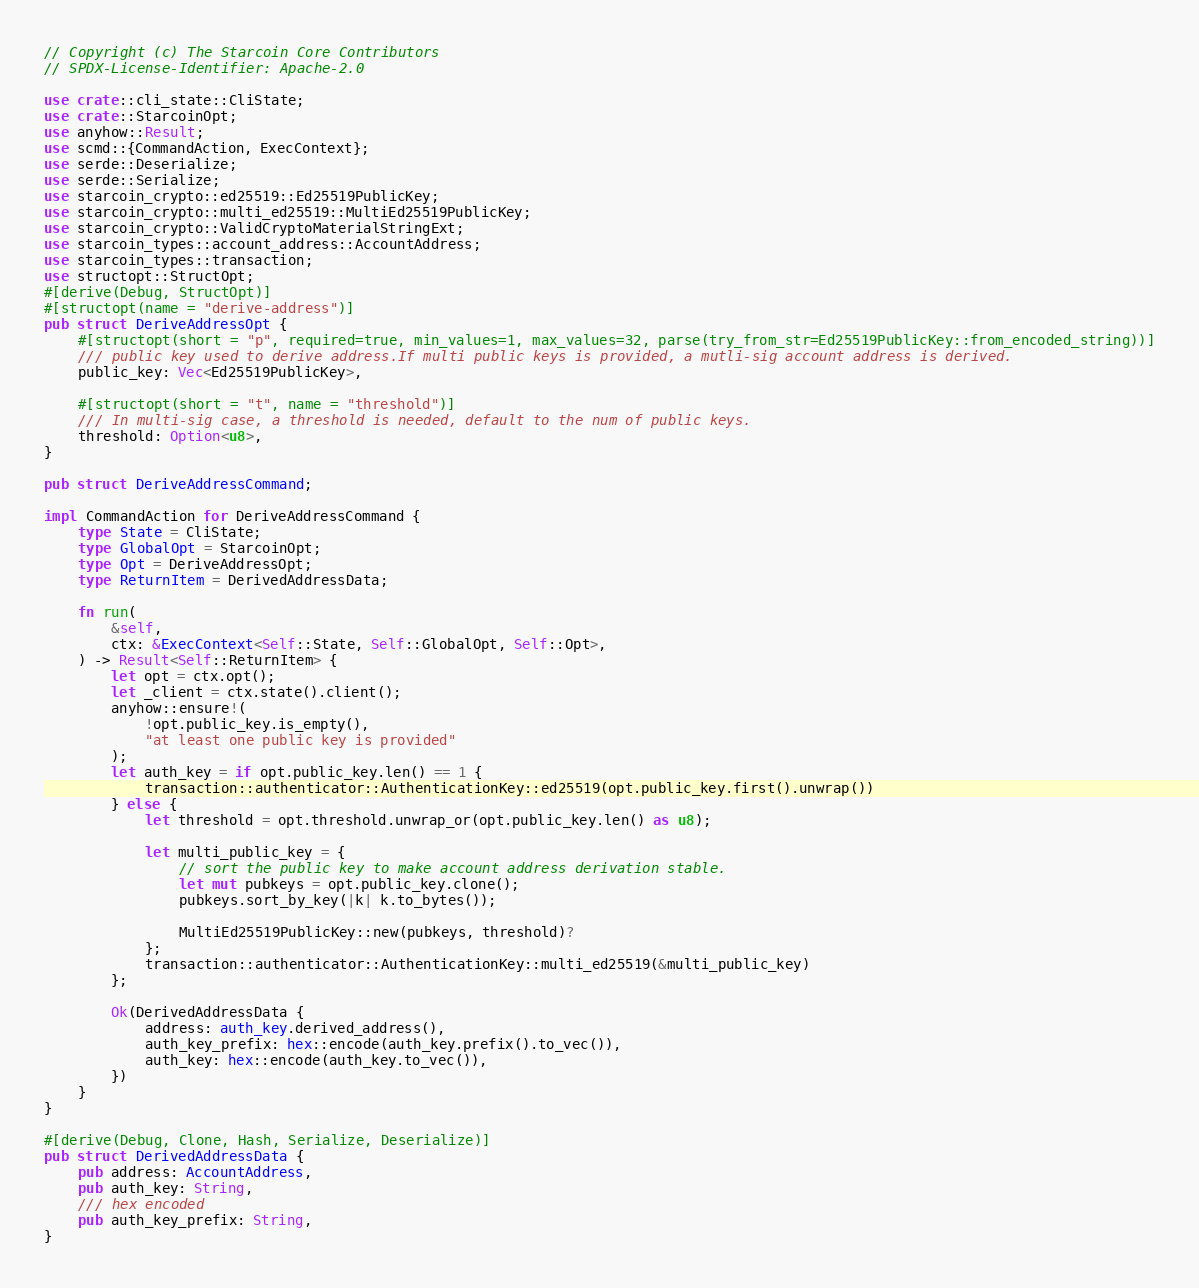Convert code to text. <code><loc_0><loc_0><loc_500><loc_500><_Rust_>// Copyright (c) The Starcoin Core Contributors
// SPDX-License-Identifier: Apache-2.0

use crate::cli_state::CliState;
use crate::StarcoinOpt;
use anyhow::Result;
use scmd::{CommandAction, ExecContext};
use serde::Deserialize;
use serde::Serialize;
use starcoin_crypto::ed25519::Ed25519PublicKey;
use starcoin_crypto::multi_ed25519::MultiEd25519PublicKey;
use starcoin_crypto::ValidCryptoMaterialStringExt;
use starcoin_types::account_address::AccountAddress;
use starcoin_types::transaction;
use structopt::StructOpt;
#[derive(Debug, StructOpt)]
#[structopt(name = "derive-address")]
pub struct DeriveAddressOpt {
    #[structopt(short = "p", required=true, min_values=1, max_values=32, parse(try_from_str=Ed25519PublicKey::from_encoded_string))]
    /// public key used to derive address.If multi public keys is provided, a mutli-sig account address is derived.
    public_key: Vec<Ed25519PublicKey>,

    #[structopt(short = "t", name = "threshold")]
    /// In multi-sig case, a threshold is needed, default to the num of public keys.
    threshold: Option<u8>,
}

pub struct DeriveAddressCommand;

impl CommandAction for DeriveAddressCommand {
    type State = CliState;
    type GlobalOpt = StarcoinOpt;
    type Opt = DeriveAddressOpt;
    type ReturnItem = DerivedAddressData;

    fn run(
        &self,
        ctx: &ExecContext<Self::State, Self::GlobalOpt, Self::Opt>,
    ) -> Result<Self::ReturnItem> {
        let opt = ctx.opt();
        let _client = ctx.state().client();
        anyhow::ensure!(
            !opt.public_key.is_empty(),
            "at least one public key is provided"
        );
        let auth_key = if opt.public_key.len() == 1 {
            transaction::authenticator::AuthenticationKey::ed25519(opt.public_key.first().unwrap())
        } else {
            let threshold = opt.threshold.unwrap_or(opt.public_key.len() as u8);

            let multi_public_key = {
                // sort the public key to make account address derivation stable.
                let mut pubkeys = opt.public_key.clone();
                pubkeys.sort_by_key(|k| k.to_bytes());

                MultiEd25519PublicKey::new(pubkeys, threshold)?
            };
            transaction::authenticator::AuthenticationKey::multi_ed25519(&multi_public_key)
        };

        Ok(DerivedAddressData {
            address: auth_key.derived_address(),
            auth_key_prefix: hex::encode(auth_key.prefix().to_vec()),
            auth_key: hex::encode(auth_key.to_vec()),
        })
    }
}

#[derive(Debug, Clone, Hash, Serialize, Deserialize)]
pub struct DerivedAddressData {
    pub address: AccountAddress,
    pub auth_key: String,
    /// hex encoded
    pub auth_key_prefix: String,
}
</code> 